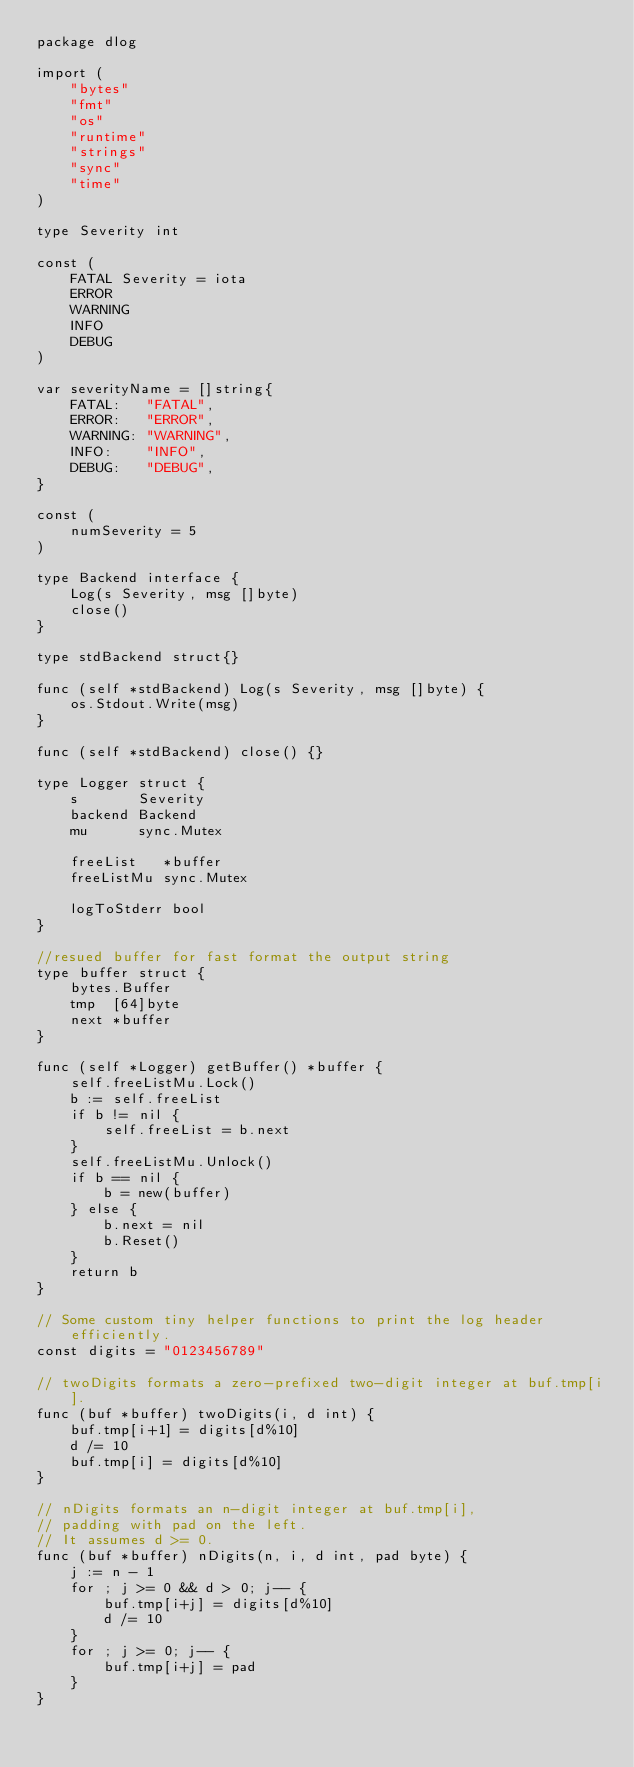Convert code to text. <code><loc_0><loc_0><loc_500><loc_500><_Go_>package dlog

import (
	"bytes"
	"fmt"
	"os"
	"runtime"
	"strings"
	"sync"
	"time"
)

type Severity int

const (
	FATAL Severity = iota
	ERROR
	WARNING
	INFO
	DEBUG
)

var severityName = []string{
	FATAL:   "FATAL",
	ERROR:   "ERROR",
	WARNING: "WARNING",
	INFO:    "INFO",
	DEBUG:   "DEBUG",
}

const (
	numSeverity = 5
)

type Backend interface {
	Log(s Severity, msg []byte)
	close()
}

type stdBackend struct{}

func (self *stdBackend) Log(s Severity, msg []byte) {
	os.Stdout.Write(msg)
}

func (self *stdBackend) close() {}

type Logger struct {
	s       Severity
	backend Backend
	mu      sync.Mutex

	freeList   *buffer
	freeListMu sync.Mutex

	logToStderr bool
}

//resued buffer for fast format the output string
type buffer struct {
	bytes.Buffer
	tmp  [64]byte
	next *buffer
}

func (self *Logger) getBuffer() *buffer {
	self.freeListMu.Lock()
	b := self.freeList
	if b != nil {
		self.freeList = b.next
	}
	self.freeListMu.Unlock()
	if b == nil {
		b = new(buffer)
	} else {
		b.next = nil
		b.Reset()
	}
	return b
}

// Some custom tiny helper functions to print the log header efficiently.
const digits = "0123456789"

// twoDigits formats a zero-prefixed two-digit integer at buf.tmp[i].
func (buf *buffer) twoDigits(i, d int) {
	buf.tmp[i+1] = digits[d%10]
	d /= 10
	buf.tmp[i] = digits[d%10]
}

// nDigits formats an n-digit integer at buf.tmp[i],
// padding with pad on the left.
// It assumes d >= 0.
func (buf *buffer) nDigits(n, i, d int, pad byte) {
	j := n - 1
	for ; j >= 0 && d > 0; j-- {
		buf.tmp[i+j] = digits[d%10]
		d /= 10
	}
	for ; j >= 0; j-- {
		buf.tmp[i+j] = pad
	}
}
</code> 